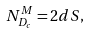Convert formula to latex. <formula><loc_0><loc_0><loc_500><loc_500>N _ { D _ { c } } ^ { M } = 2 d S ,</formula> 